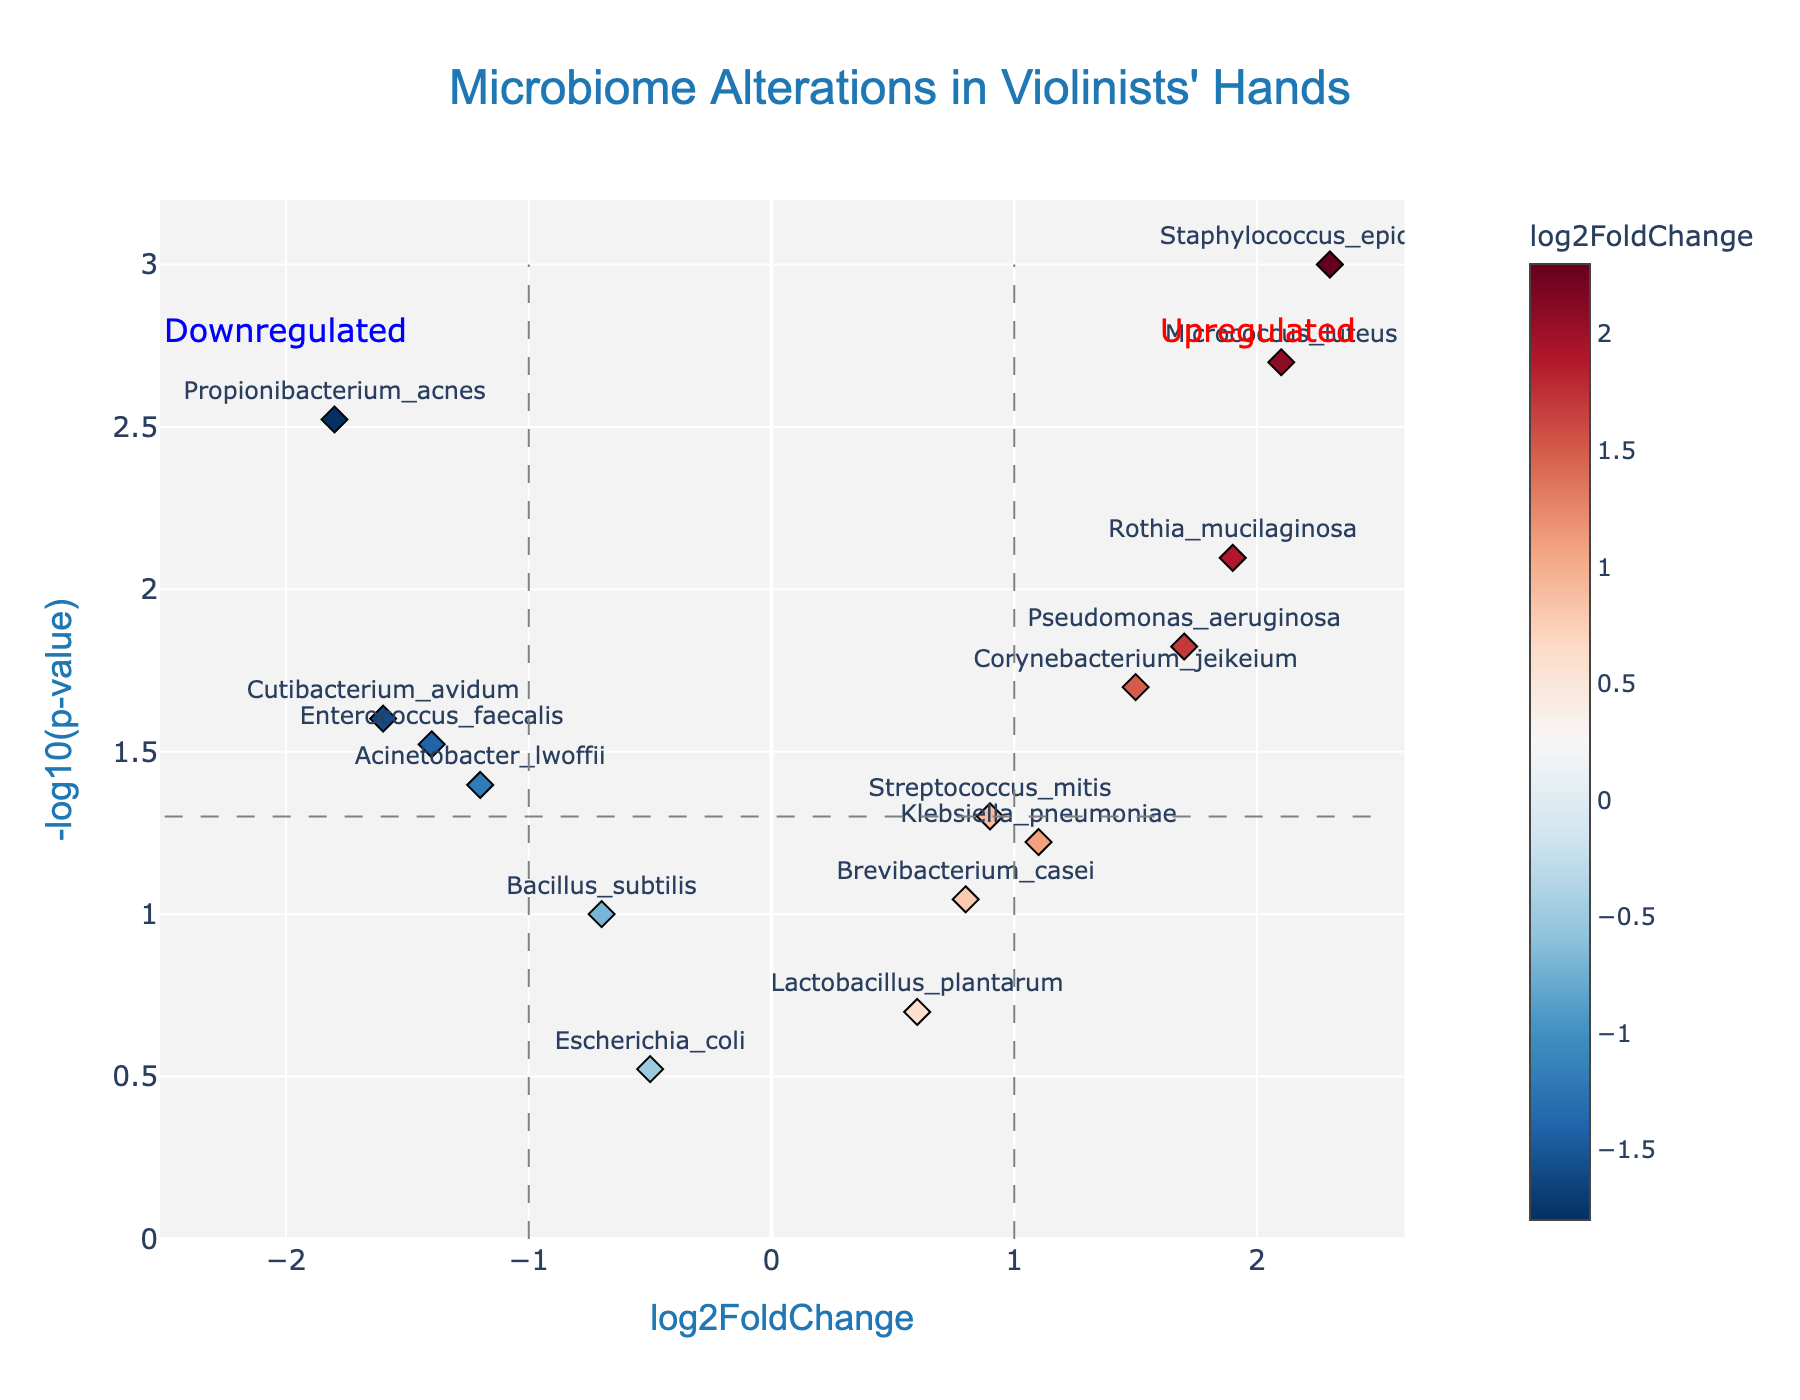What is the title of the plot? The title is generally displayed at the top of the plot. In this case, it reads: "Microbiome Alterations in Violinists' Hands".
Answer: Microbiome Alterations in Violinists' Hands How many genes have a log2FoldChange greater than 1? To answer this, we count the points on the plot that are to the right of the vertical line at log2FoldChange = 1. These points represent genes with a log2FoldChange greater than 1.
Answer: 5 Which gene has the highest -log10(p-value)? To find this, we identify the point that is the highest on the y-axis. The gene represented by this point has the highest -log10(p-value).
Answer: Staphylococcus_epidermidis Which gene is most down-regulated, and where is it located on the plot? Down-regulation is represented by negative log2FoldChange values. The gene farthest to the left on the x-axis is most down-regulated.
Answer: Propionibacterium_acnes Are there more upregulated or downregulated genes with significant p-values? We look at the number of points to the right of the vertical log2FoldChange = 1 line (upregulated) and those to the left of the log2FoldChange = -1 line (downregulated) with -log10(p-value) above the horizontal significance threshold line.
Answer: More upregulated Which genes have log2FoldChange values between -1 and 1 with significant p-values? We identify points between the vertical lines at log2FoldChange = -1 and log2FoldChange = 1 and above the significance threshold line. These genes have moderate fold changes with significant p-values.
Answer: Corynebacterium_jeikeium, Pseudomonas_aeruginosa, Rothia_mucilaginosa How many genes are labeled on the plot? Each data point is labeled with a gene name. By counting these labels, we can determine the number of genes being displayed on the plot.
Answer: 14 Which gene is closest to the (0, 0) point on the plot, and what does this imply about its log2FoldChange and p-value? The (0, 0) point corresponds to a log2FoldChange of 0 and a p-value of 1. The gene closest to this point would have values close to no change and non-significance.
Answer: Escherichia_coli If a line is drawn vertically through log2FoldChange = 1, which genes fall on this line and what is their significance? By observing the vertical line at log2FoldChange = 1, we can note which data points fall directly on it and check their y-values for significance.
Answer: Klebsiella_pneumoniae (not significant) 